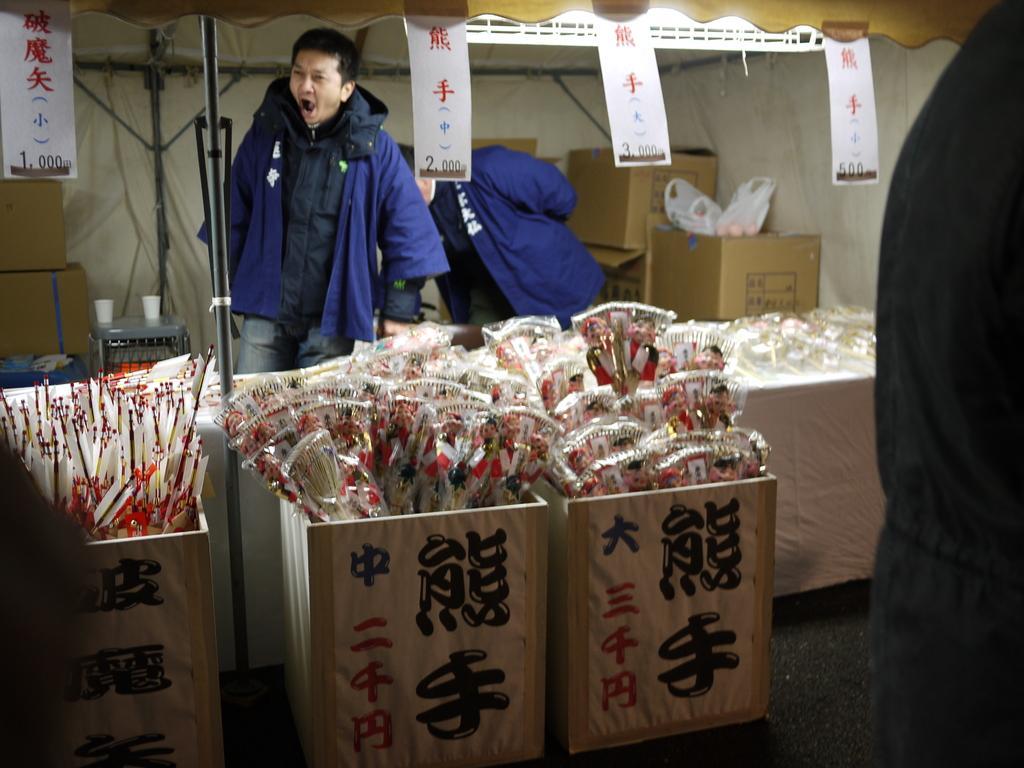Can you describe this image briefly? As we can see in the image there is a man wearing blue color jacket, boxes, white color wall, stool and banners. On stool there are two glasses. 